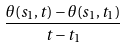Convert formula to latex. <formula><loc_0><loc_0><loc_500><loc_500>\frac { \theta ( s _ { 1 } , t ) - \theta ( s _ { 1 } , t _ { 1 } ) } { t - t _ { 1 } }</formula> 